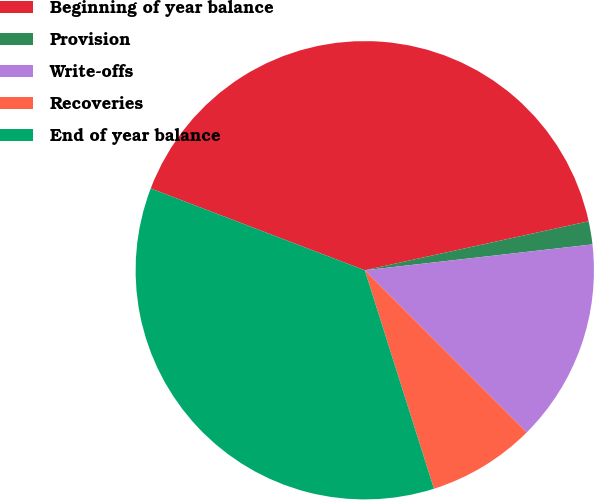Convert chart. <chart><loc_0><loc_0><loc_500><loc_500><pie_chart><fcel>Beginning of year balance<fcel>Provision<fcel>Write-offs<fcel>Recoveries<fcel>End of year balance<nl><fcel>40.76%<fcel>1.63%<fcel>14.31%<fcel>7.61%<fcel>35.69%<nl></chart> 